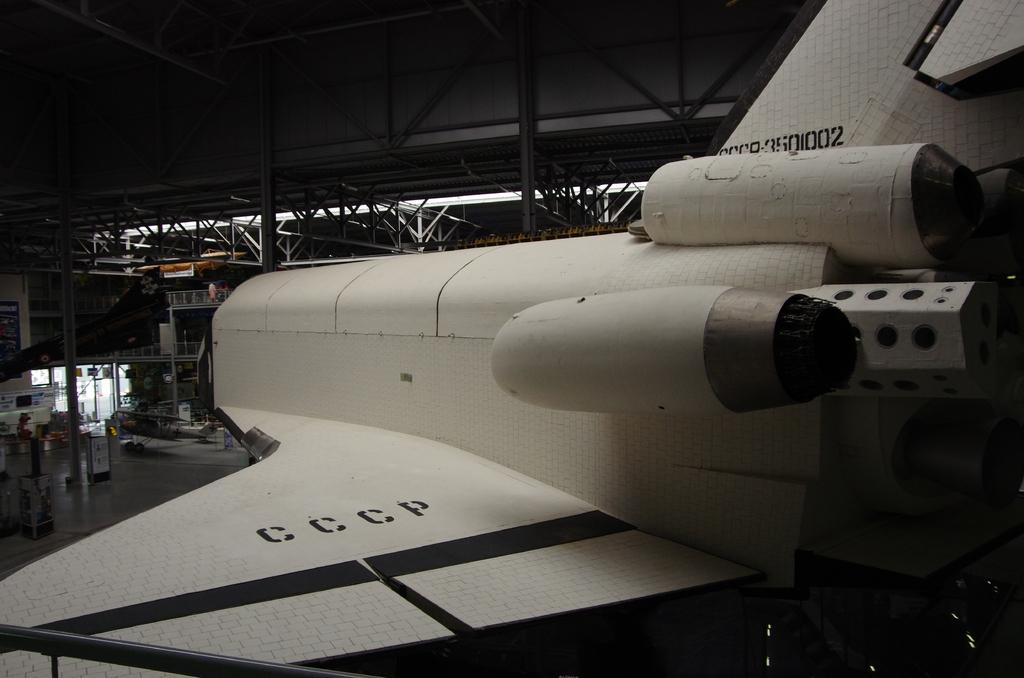What type of vehicle is on the floor in the image? There is a white aircraft on the floor in the image. What other equipment can be seen in the image? There is another equipment visible in the background. What type of roof is present in the image? There is a metal roof in the image. What type of furniture is being repaired by the carpenter in the image? There is no carpenter or furniture present in the image. How many patches can be seen on the aircraft in the image? There is no mention of patches on the aircraft in the provided facts, so it cannot be determined from the image. 